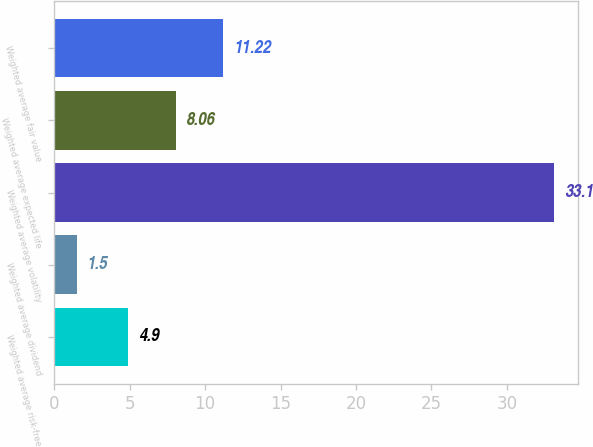<chart> <loc_0><loc_0><loc_500><loc_500><bar_chart><fcel>Weighted average risk-free<fcel>Weighted average dividend<fcel>Weighted average volatility<fcel>Weighted average expected life<fcel>Weighted average fair value<nl><fcel>4.9<fcel>1.5<fcel>33.1<fcel>8.06<fcel>11.22<nl></chart> 